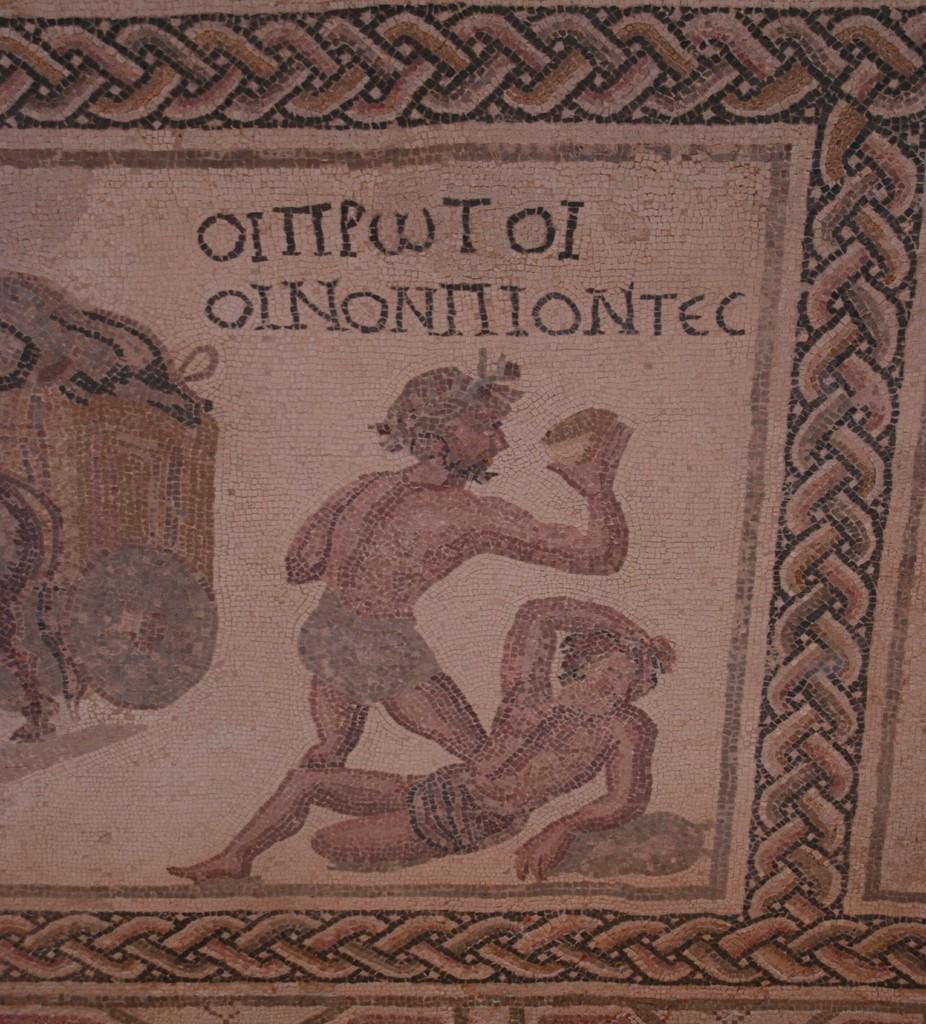What is the main subject of the image? The main subject of the image is a cloth. What is depicted on the cloth? The cloth has a print of two persons. What are the actions of the persons in the print? One person is lying, and the other person is walking in the print. What is the walking person holding in the print? The walking person is holding an object in the print. What type of flesh can be seen on the page in the image? There is no page or flesh present in the image; it features a cloth with a print of two persons. Is there a stove visible in the image? There is no stove present in the image. 